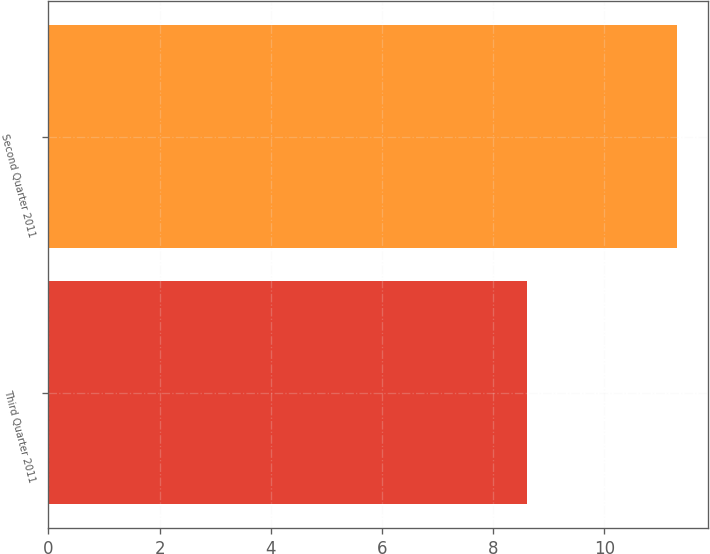Convert chart to OTSL. <chart><loc_0><loc_0><loc_500><loc_500><bar_chart><fcel>Third Quarter 2011<fcel>Second Quarter 2011<nl><fcel>8.6<fcel>11.3<nl></chart> 